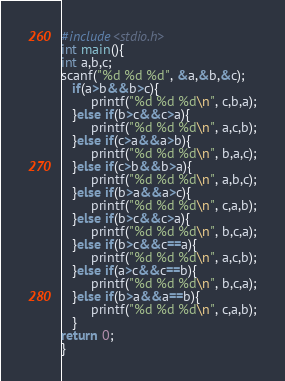Convert code to text. <code><loc_0><loc_0><loc_500><loc_500><_C_>#include<stdio.h>
int main(){
int a,b,c;
scanf("%d %d %d", &a,&b,&c);
   if(a>b&&b>c){
        printf("%d %d %d\n", c,b,a);
   }else if(b>c&&c>a){
        printf("%d %d %d\n", a,c,b);
   }else if(c>a&&a>b){
        printf("%d %d %d\n", b,a,c);
   }else if(c>b&&b>a){
        printf("%d %d %d\n", a,b,c);
   }else if(b>a&&a>c){
        printf("%d %d %d\n", c,a,b);
   }else if(b>c&&c>a){
        printf("%d %d %d\n", b,c,a);
   }else if(b>c&&c==a){
        printf("%d %d %d\n", a,c,b);
   }else if(a>c&&c==b){
        printf("%d %d %d\n", b,c,a);
   }else if(b>a&&a==b){
        printf("%d %d %d\n", c,a,b);
   }
return 0;
}</code> 